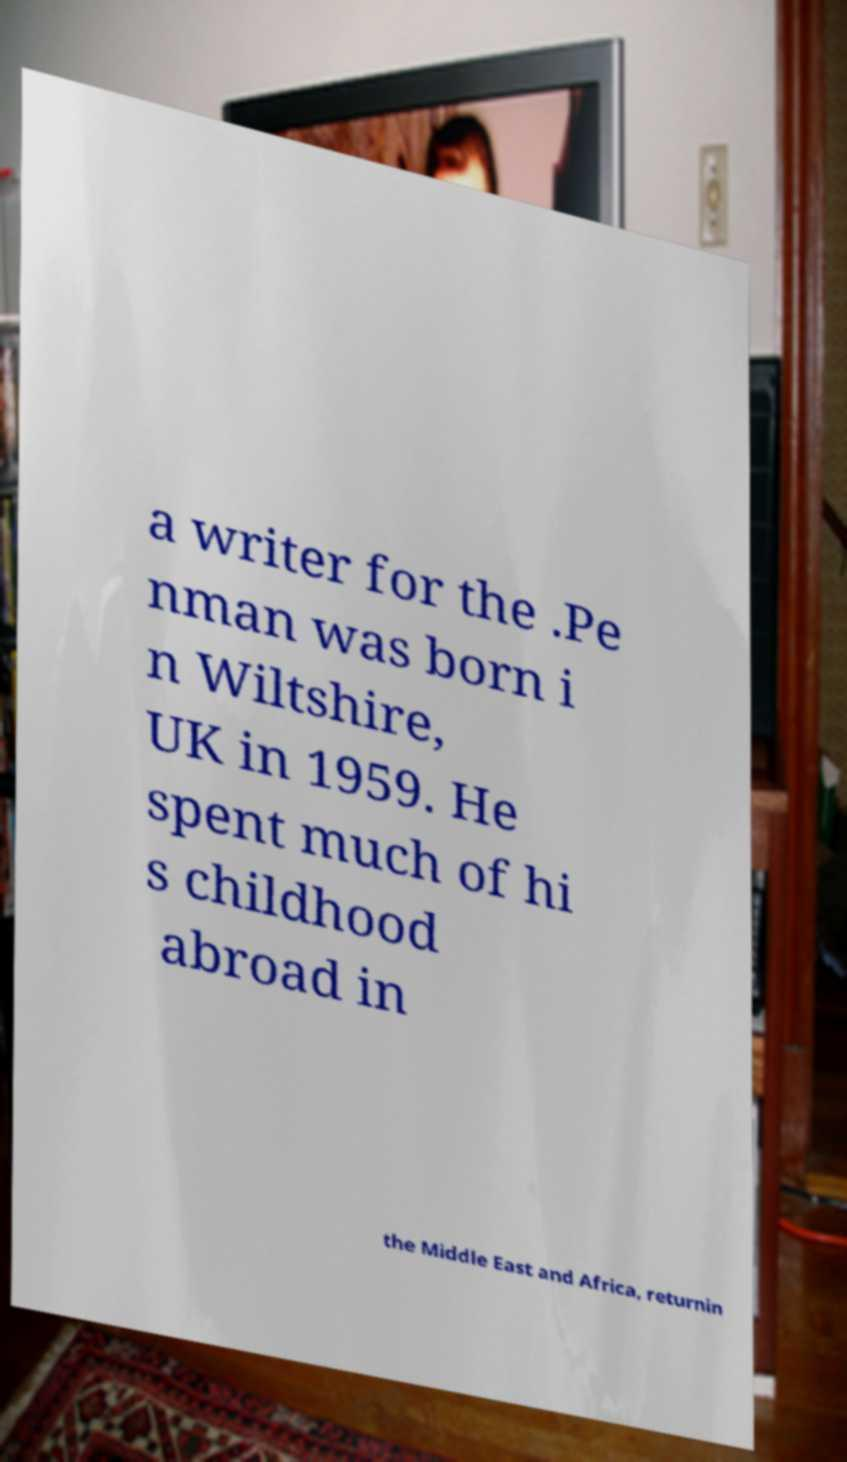Please identify and transcribe the text found in this image. a writer for the .Pe nman was born i n Wiltshire, UK in 1959. He spent much of hi s childhood abroad in the Middle East and Africa, returnin 